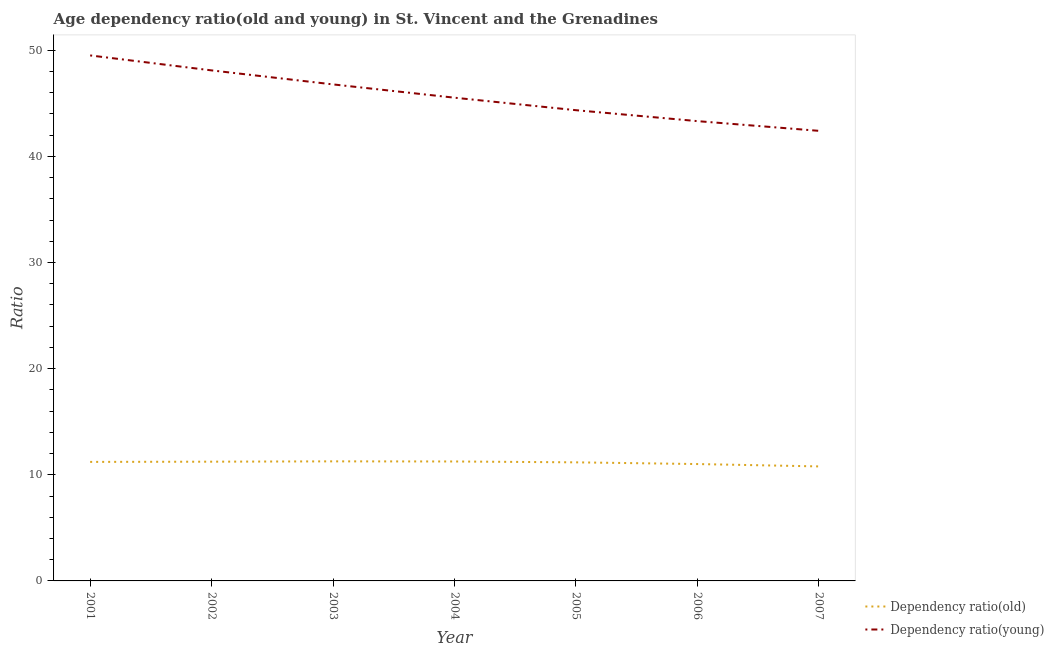How many different coloured lines are there?
Keep it short and to the point. 2. Does the line corresponding to age dependency ratio(young) intersect with the line corresponding to age dependency ratio(old)?
Make the answer very short. No. What is the age dependency ratio(young) in 2007?
Offer a terse response. 42.41. Across all years, what is the maximum age dependency ratio(old)?
Keep it short and to the point. 11.27. Across all years, what is the minimum age dependency ratio(young)?
Ensure brevity in your answer.  42.41. In which year was the age dependency ratio(old) maximum?
Provide a short and direct response. 2003. In which year was the age dependency ratio(young) minimum?
Make the answer very short. 2007. What is the total age dependency ratio(young) in the graph?
Offer a terse response. 320.03. What is the difference between the age dependency ratio(young) in 2006 and that in 2007?
Offer a terse response. 0.91. What is the difference between the age dependency ratio(young) in 2002 and the age dependency ratio(old) in 2007?
Make the answer very short. 37.32. What is the average age dependency ratio(old) per year?
Provide a short and direct response. 11.14. In the year 2003, what is the difference between the age dependency ratio(old) and age dependency ratio(young)?
Provide a succinct answer. -35.52. What is the ratio of the age dependency ratio(young) in 2001 to that in 2002?
Your response must be concise. 1.03. Is the age dependency ratio(young) in 2005 less than that in 2006?
Give a very brief answer. No. What is the difference between the highest and the second highest age dependency ratio(old)?
Your response must be concise. 0.01. What is the difference between the highest and the lowest age dependency ratio(old)?
Give a very brief answer. 0.48. In how many years, is the age dependency ratio(old) greater than the average age dependency ratio(old) taken over all years?
Your answer should be very brief. 5. Does the age dependency ratio(old) monotonically increase over the years?
Ensure brevity in your answer.  No. Is the age dependency ratio(old) strictly greater than the age dependency ratio(young) over the years?
Make the answer very short. No. Is the age dependency ratio(young) strictly less than the age dependency ratio(old) over the years?
Offer a very short reply. No. How many years are there in the graph?
Ensure brevity in your answer.  7. Are the values on the major ticks of Y-axis written in scientific E-notation?
Your answer should be compact. No. Does the graph contain any zero values?
Offer a terse response. No. How many legend labels are there?
Your answer should be very brief. 2. What is the title of the graph?
Provide a succinct answer. Age dependency ratio(old and young) in St. Vincent and the Grenadines. What is the label or title of the Y-axis?
Provide a succinct answer. Ratio. What is the Ratio in Dependency ratio(old) in 2001?
Your response must be concise. 11.22. What is the Ratio in Dependency ratio(young) in 2001?
Offer a terse response. 49.52. What is the Ratio of Dependency ratio(old) in 2002?
Your answer should be compact. 11.24. What is the Ratio of Dependency ratio(young) in 2002?
Provide a succinct answer. 48.11. What is the Ratio of Dependency ratio(old) in 2003?
Give a very brief answer. 11.27. What is the Ratio of Dependency ratio(young) in 2003?
Your response must be concise. 46.79. What is the Ratio of Dependency ratio(old) in 2004?
Make the answer very short. 11.25. What is the Ratio in Dependency ratio(young) in 2004?
Ensure brevity in your answer.  45.53. What is the Ratio in Dependency ratio(old) in 2005?
Give a very brief answer. 11.17. What is the Ratio in Dependency ratio(young) in 2005?
Offer a very short reply. 44.36. What is the Ratio of Dependency ratio(old) in 2006?
Make the answer very short. 11.01. What is the Ratio of Dependency ratio(young) in 2006?
Offer a very short reply. 43.32. What is the Ratio of Dependency ratio(old) in 2007?
Provide a succinct answer. 10.79. What is the Ratio in Dependency ratio(young) in 2007?
Provide a short and direct response. 42.41. Across all years, what is the maximum Ratio of Dependency ratio(old)?
Ensure brevity in your answer.  11.27. Across all years, what is the maximum Ratio in Dependency ratio(young)?
Your answer should be compact. 49.52. Across all years, what is the minimum Ratio in Dependency ratio(old)?
Keep it short and to the point. 10.79. Across all years, what is the minimum Ratio of Dependency ratio(young)?
Provide a succinct answer. 42.41. What is the total Ratio of Dependency ratio(old) in the graph?
Your answer should be compact. 77.95. What is the total Ratio in Dependency ratio(young) in the graph?
Give a very brief answer. 320.03. What is the difference between the Ratio in Dependency ratio(old) in 2001 and that in 2002?
Your answer should be very brief. -0.02. What is the difference between the Ratio in Dependency ratio(young) in 2001 and that in 2002?
Give a very brief answer. 1.41. What is the difference between the Ratio of Dependency ratio(old) in 2001 and that in 2003?
Offer a terse response. -0.05. What is the difference between the Ratio of Dependency ratio(young) in 2001 and that in 2003?
Your response must be concise. 2.73. What is the difference between the Ratio of Dependency ratio(old) in 2001 and that in 2004?
Make the answer very short. -0.04. What is the difference between the Ratio of Dependency ratio(young) in 2001 and that in 2004?
Your answer should be compact. 3.98. What is the difference between the Ratio in Dependency ratio(old) in 2001 and that in 2005?
Your answer should be compact. 0.04. What is the difference between the Ratio of Dependency ratio(young) in 2001 and that in 2005?
Make the answer very short. 5.16. What is the difference between the Ratio of Dependency ratio(old) in 2001 and that in 2006?
Provide a short and direct response. 0.2. What is the difference between the Ratio of Dependency ratio(young) in 2001 and that in 2006?
Offer a terse response. 6.19. What is the difference between the Ratio of Dependency ratio(old) in 2001 and that in 2007?
Offer a terse response. 0.43. What is the difference between the Ratio of Dependency ratio(young) in 2001 and that in 2007?
Your answer should be very brief. 7.11. What is the difference between the Ratio in Dependency ratio(old) in 2002 and that in 2003?
Keep it short and to the point. -0.03. What is the difference between the Ratio of Dependency ratio(young) in 2002 and that in 2003?
Provide a succinct answer. 1.32. What is the difference between the Ratio in Dependency ratio(old) in 2002 and that in 2004?
Keep it short and to the point. -0.02. What is the difference between the Ratio of Dependency ratio(young) in 2002 and that in 2004?
Your answer should be compact. 2.57. What is the difference between the Ratio of Dependency ratio(old) in 2002 and that in 2005?
Your answer should be very brief. 0.06. What is the difference between the Ratio of Dependency ratio(young) in 2002 and that in 2005?
Your response must be concise. 3.75. What is the difference between the Ratio of Dependency ratio(old) in 2002 and that in 2006?
Provide a succinct answer. 0.22. What is the difference between the Ratio in Dependency ratio(young) in 2002 and that in 2006?
Make the answer very short. 4.78. What is the difference between the Ratio in Dependency ratio(old) in 2002 and that in 2007?
Keep it short and to the point. 0.45. What is the difference between the Ratio in Dependency ratio(young) in 2002 and that in 2007?
Your response must be concise. 5.7. What is the difference between the Ratio in Dependency ratio(old) in 2003 and that in 2004?
Ensure brevity in your answer.  0.01. What is the difference between the Ratio of Dependency ratio(young) in 2003 and that in 2004?
Offer a terse response. 1.25. What is the difference between the Ratio in Dependency ratio(old) in 2003 and that in 2005?
Keep it short and to the point. 0.09. What is the difference between the Ratio in Dependency ratio(young) in 2003 and that in 2005?
Your answer should be very brief. 2.43. What is the difference between the Ratio of Dependency ratio(old) in 2003 and that in 2006?
Offer a very short reply. 0.25. What is the difference between the Ratio in Dependency ratio(young) in 2003 and that in 2006?
Provide a succinct answer. 3.46. What is the difference between the Ratio of Dependency ratio(old) in 2003 and that in 2007?
Ensure brevity in your answer.  0.48. What is the difference between the Ratio of Dependency ratio(young) in 2003 and that in 2007?
Offer a terse response. 4.37. What is the difference between the Ratio in Dependency ratio(old) in 2004 and that in 2005?
Your response must be concise. 0.08. What is the difference between the Ratio in Dependency ratio(young) in 2004 and that in 2005?
Offer a terse response. 1.18. What is the difference between the Ratio of Dependency ratio(old) in 2004 and that in 2006?
Ensure brevity in your answer.  0.24. What is the difference between the Ratio in Dependency ratio(young) in 2004 and that in 2006?
Your response must be concise. 2.21. What is the difference between the Ratio in Dependency ratio(old) in 2004 and that in 2007?
Your answer should be compact. 0.47. What is the difference between the Ratio in Dependency ratio(young) in 2004 and that in 2007?
Your response must be concise. 3.12. What is the difference between the Ratio of Dependency ratio(old) in 2005 and that in 2006?
Your response must be concise. 0.16. What is the difference between the Ratio of Dependency ratio(young) in 2005 and that in 2006?
Your response must be concise. 1.03. What is the difference between the Ratio in Dependency ratio(old) in 2005 and that in 2007?
Provide a succinct answer. 0.38. What is the difference between the Ratio in Dependency ratio(young) in 2005 and that in 2007?
Offer a very short reply. 1.94. What is the difference between the Ratio of Dependency ratio(old) in 2006 and that in 2007?
Ensure brevity in your answer.  0.22. What is the difference between the Ratio in Dependency ratio(young) in 2006 and that in 2007?
Offer a very short reply. 0.91. What is the difference between the Ratio of Dependency ratio(old) in 2001 and the Ratio of Dependency ratio(young) in 2002?
Your answer should be compact. -36.89. What is the difference between the Ratio in Dependency ratio(old) in 2001 and the Ratio in Dependency ratio(young) in 2003?
Your response must be concise. -35.57. What is the difference between the Ratio in Dependency ratio(old) in 2001 and the Ratio in Dependency ratio(young) in 2004?
Ensure brevity in your answer.  -34.32. What is the difference between the Ratio in Dependency ratio(old) in 2001 and the Ratio in Dependency ratio(young) in 2005?
Your answer should be compact. -33.14. What is the difference between the Ratio of Dependency ratio(old) in 2001 and the Ratio of Dependency ratio(young) in 2006?
Offer a terse response. -32.11. What is the difference between the Ratio of Dependency ratio(old) in 2001 and the Ratio of Dependency ratio(young) in 2007?
Offer a terse response. -31.2. What is the difference between the Ratio of Dependency ratio(old) in 2002 and the Ratio of Dependency ratio(young) in 2003?
Offer a very short reply. -35.55. What is the difference between the Ratio of Dependency ratio(old) in 2002 and the Ratio of Dependency ratio(young) in 2004?
Your response must be concise. -34.3. What is the difference between the Ratio of Dependency ratio(old) in 2002 and the Ratio of Dependency ratio(young) in 2005?
Give a very brief answer. -33.12. What is the difference between the Ratio of Dependency ratio(old) in 2002 and the Ratio of Dependency ratio(young) in 2006?
Make the answer very short. -32.09. What is the difference between the Ratio in Dependency ratio(old) in 2002 and the Ratio in Dependency ratio(young) in 2007?
Keep it short and to the point. -31.17. What is the difference between the Ratio in Dependency ratio(old) in 2003 and the Ratio in Dependency ratio(young) in 2004?
Your response must be concise. -34.27. What is the difference between the Ratio in Dependency ratio(old) in 2003 and the Ratio in Dependency ratio(young) in 2005?
Your response must be concise. -33.09. What is the difference between the Ratio of Dependency ratio(old) in 2003 and the Ratio of Dependency ratio(young) in 2006?
Ensure brevity in your answer.  -32.06. What is the difference between the Ratio of Dependency ratio(old) in 2003 and the Ratio of Dependency ratio(young) in 2007?
Ensure brevity in your answer.  -31.14. What is the difference between the Ratio of Dependency ratio(old) in 2004 and the Ratio of Dependency ratio(young) in 2005?
Keep it short and to the point. -33.1. What is the difference between the Ratio in Dependency ratio(old) in 2004 and the Ratio in Dependency ratio(young) in 2006?
Provide a succinct answer. -32.07. What is the difference between the Ratio in Dependency ratio(old) in 2004 and the Ratio in Dependency ratio(young) in 2007?
Offer a terse response. -31.16. What is the difference between the Ratio in Dependency ratio(old) in 2005 and the Ratio in Dependency ratio(young) in 2006?
Offer a terse response. -32.15. What is the difference between the Ratio in Dependency ratio(old) in 2005 and the Ratio in Dependency ratio(young) in 2007?
Offer a very short reply. -31.24. What is the difference between the Ratio of Dependency ratio(old) in 2006 and the Ratio of Dependency ratio(young) in 2007?
Provide a succinct answer. -31.4. What is the average Ratio in Dependency ratio(old) per year?
Provide a succinct answer. 11.14. What is the average Ratio of Dependency ratio(young) per year?
Make the answer very short. 45.72. In the year 2001, what is the difference between the Ratio in Dependency ratio(old) and Ratio in Dependency ratio(young)?
Offer a very short reply. -38.3. In the year 2002, what is the difference between the Ratio of Dependency ratio(old) and Ratio of Dependency ratio(young)?
Give a very brief answer. -36.87. In the year 2003, what is the difference between the Ratio of Dependency ratio(old) and Ratio of Dependency ratio(young)?
Ensure brevity in your answer.  -35.52. In the year 2004, what is the difference between the Ratio in Dependency ratio(old) and Ratio in Dependency ratio(young)?
Offer a terse response. -34.28. In the year 2005, what is the difference between the Ratio in Dependency ratio(old) and Ratio in Dependency ratio(young)?
Your answer should be compact. -33.18. In the year 2006, what is the difference between the Ratio of Dependency ratio(old) and Ratio of Dependency ratio(young)?
Your answer should be compact. -32.31. In the year 2007, what is the difference between the Ratio in Dependency ratio(old) and Ratio in Dependency ratio(young)?
Give a very brief answer. -31.62. What is the ratio of the Ratio of Dependency ratio(young) in 2001 to that in 2002?
Your answer should be very brief. 1.03. What is the ratio of the Ratio in Dependency ratio(young) in 2001 to that in 2003?
Your response must be concise. 1.06. What is the ratio of the Ratio in Dependency ratio(old) in 2001 to that in 2004?
Provide a succinct answer. 1. What is the ratio of the Ratio in Dependency ratio(young) in 2001 to that in 2004?
Provide a succinct answer. 1.09. What is the ratio of the Ratio of Dependency ratio(young) in 2001 to that in 2005?
Offer a very short reply. 1.12. What is the ratio of the Ratio in Dependency ratio(old) in 2001 to that in 2006?
Give a very brief answer. 1.02. What is the ratio of the Ratio in Dependency ratio(old) in 2001 to that in 2007?
Offer a very short reply. 1.04. What is the ratio of the Ratio of Dependency ratio(young) in 2001 to that in 2007?
Provide a succinct answer. 1.17. What is the ratio of the Ratio of Dependency ratio(young) in 2002 to that in 2003?
Your response must be concise. 1.03. What is the ratio of the Ratio in Dependency ratio(old) in 2002 to that in 2004?
Offer a terse response. 1. What is the ratio of the Ratio of Dependency ratio(young) in 2002 to that in 2004?
Provide a short and direct response. 1.06. What is the ratio of the Ratio of Dependency ratio(old) in 2002 to that in 2005?
Your answer should be very brief. 1.01. What is the ratio of the Ratio in Dependency ratio(young) in 2002 to that in 2005?
Keep it short and to the point. 1.08. What is the ratio of the Ratio of Dependency ratio(old) in 2002 to that in 2006?
Provide a short and direct response. 1.02. What is the ratio of the Ratio of Dependency ratio(young) in 2002 to that in 2006?
Make the answer very short. 1.11. What is the ratio of the Ratio of Dependency ratio(old) in 2002 to that in 2007?
Your response must be concise. 1.04. What is the ratio of the Ratio in Dependency ratio(young) in 2002 to that in 2007?
Give a very brief answer. 1.13. What is the ratio of the Ratio of Dependency ratio(young) in 2003 to that in 2004?
Your answer should be compact. 1.03. What is the ratio of the Ratio in Dependency ratio(old) in 2003 to that in 2005?
Keep it short and to the point. 1.01. What is the ratio of the Ratio of Dependency ratio(young) in 2003 to that in 2005?
Your response must be concise. 1.05. What is the ratio of the Ratio of Dependency ratio(old) in 2003 to that in 2006?
Provide a succinct answer. 1.02. What is the ratio of the Ratio in Dependency ratio(young) in 2003 to that in 2006?
Make the answer very short. 1.08. What is the ratio of the Ratio of Dependency ratio(old) in 2003 to that in 2007?
Provide a short and direct response. 1.04. What is the ratio of the Ratio in Dependency ratio(young) in 2003 to that in 2007?
Your answer should be very brief. 1.1. What is the ratio of the Ratio of Dependency ratio(old) in 2004 to that in 2005?
Your answer should be very brief. 1.01. What is the ratio of the Ratio in Dependency ratio(young) in 2004 to that in 2005?
Offer a very short reply. 1.03. What is the ratio of the Ratio in Dependency ratio(young) in 2004 to that in 2006?
Ensure brevity in your answer.  1.05. What is the ratio of the Ratio in Dependency ratio(old) in 2004 to that in 2007?
Make the answer very short. 1.04. What is the ratio of the Ratio of Dependency ratio(young) in 2004 to that in 2007?
Your answer should be compact. 1.07. What is the ratio of the Ratio in Dependency ratio(old) in 2005 to that in 2006?
Offer a terse response. 1.01. What is the ratio of the Ratio of Dependency ratio(young) in 2005 to that in 2006?
Your response must be concise. 1.02. What is the ratio of the Ratio of Dependency ratio(old) in 2005 to that in 2007?
Give a very brief answer. 1.04. What is the ratio of the Ratio of Dependency ratio(young) in 2005 to that in 2007?
Your response must be concise. 1.05. What is the ratio of the Ratio of Dependency ratio(old) in 2006 to that in 2007?
Make the answer very short. 1.02. What is the ratio of the Ratio in Dependency ratio(young) in 2006 to that in 2007?
Your response must be concise. 1.02. What is the difference between the highest and the second highest Ratio in Dependency ratio(old)?
Provide a short and direct response. 0.01. What is the difference between the highest and the second highest Ratio of Dependency ratio(young)?
Your response must be concise. 1.41. What is the difference between the highest and the lowest Ratio of Dependency ratio(old)?
Your answer should be compact. 0.48. What is the difference between the highest and the lowest Ratio in Dependency ratio(young)?
Ensure brevity in your answer.  7.11. 